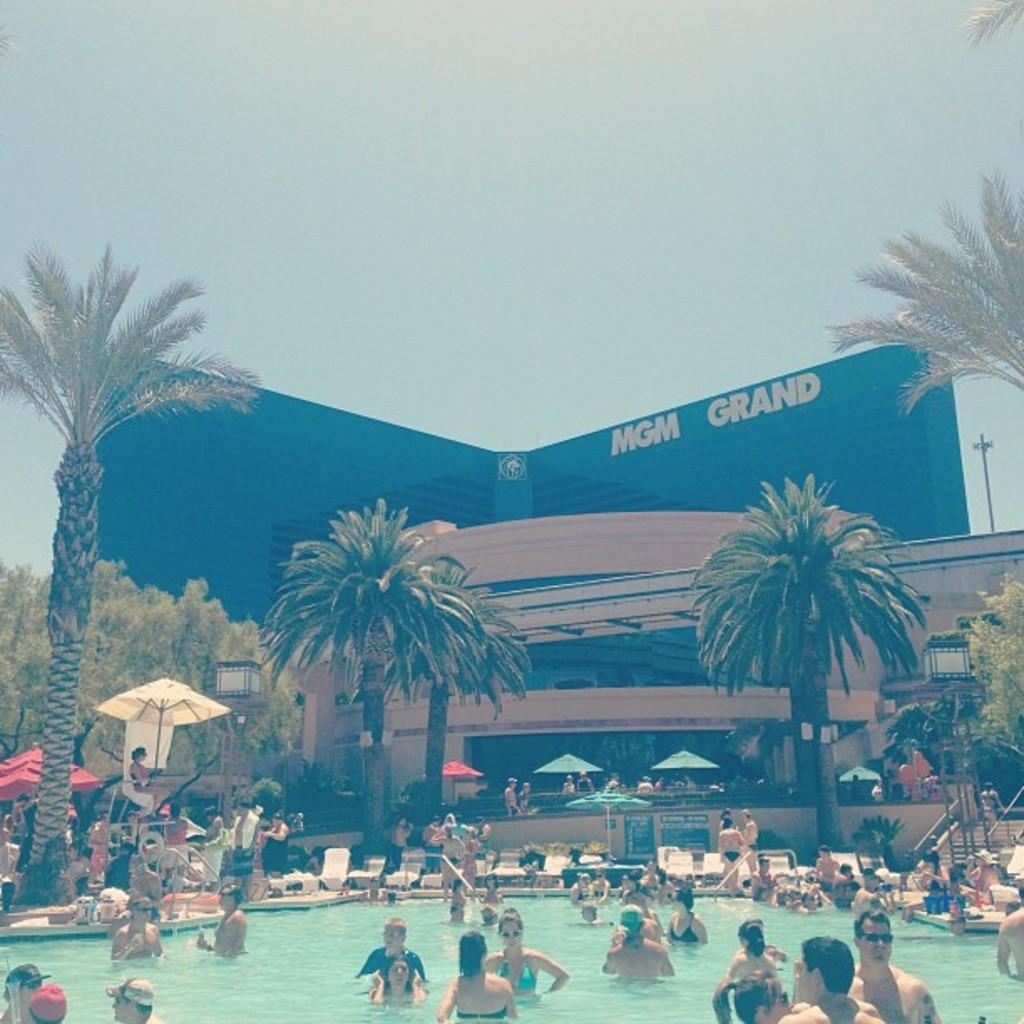What is the main feature in the image? There is a swimming pool in the image. What is happening in the swimming pool? There are many people in the swimming pool. What can be seen in the background of the image? There are umbrellas, trees, buildings, and the sky visible in the background of the image. Where are the steps located in the image? The steps are on the right side of the image. What type of plastic material is being used to create light in the image? There is no plastic material or light source mentioned in the image; it features a swimming pool with people and background elements. 